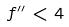Convert formula to latex. <formula><loc_0><loc_0><loc_500><loc_500>f ^ { \prime \prime } < 4</formula> 